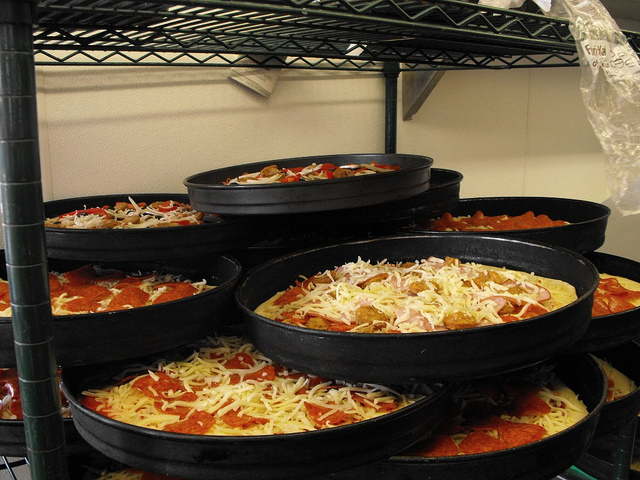Please provide the bounding box coordinate of the region this sentence describes: closest full pizza visible. The closest full pizza visible in the image is located in the bottom center, clearly seen with a generous amount of pepperoni and cheese mostly covered, yet still visible. The bounding box coordinates are approximately [0.4, 0.53, 0.9, 0.64]. 